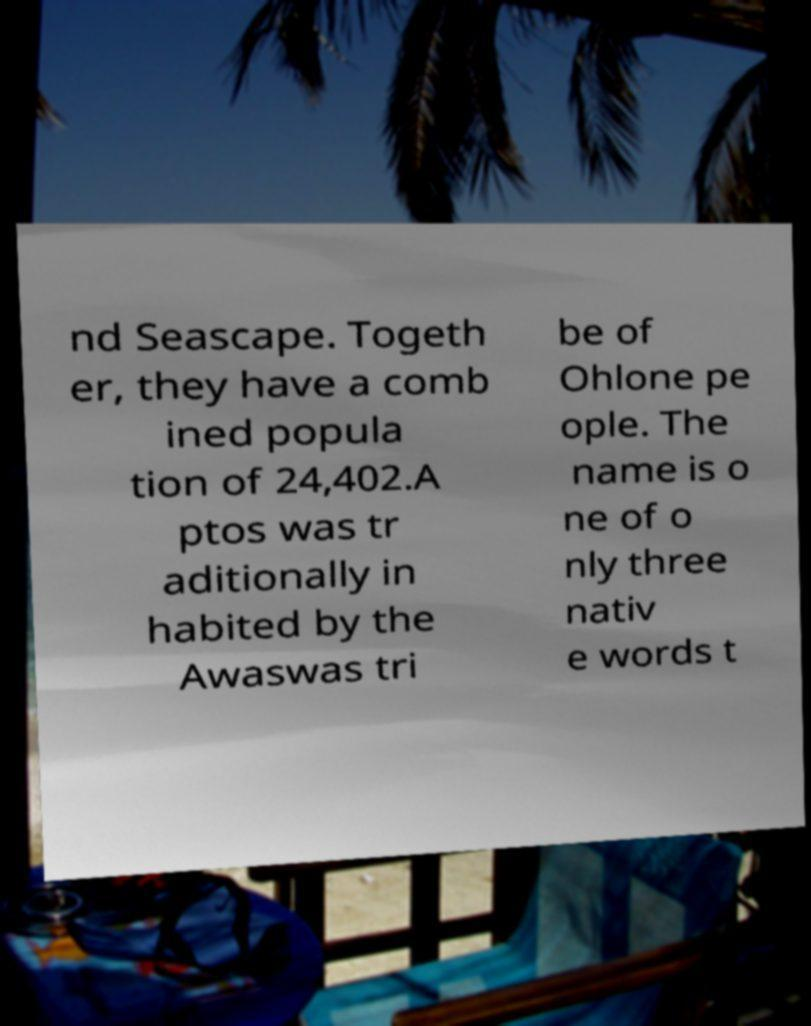Please identify and transcribe the text found in this image. nd Seascape. Togeth er, they have a comb ined popula tion of 24,402.A ptos was tr aditionally in habited by the Awaswas tri be of Ohlone pe ople. The name is o ne of o nly three nativ e words t 